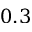Convert formula to latex. <formula><loc_0><loc_0><loc_500><loc_500>0 . 3</formula> 